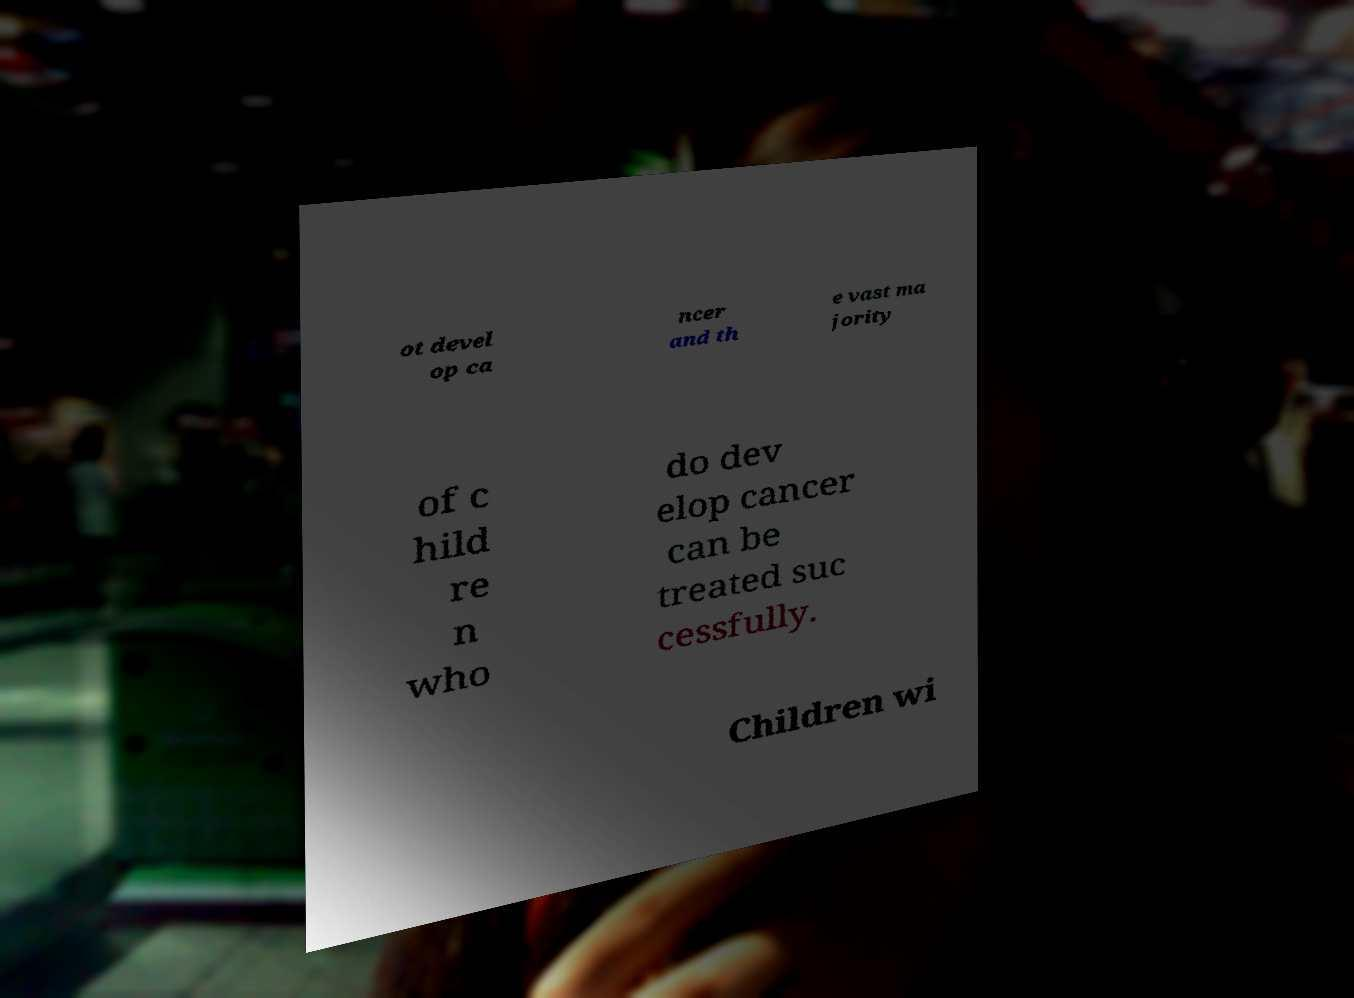There's text embedded in this image that I need extracted. Can you transcribe it verbatim? ot devel op ca ncer and th e vast ma jority of c hild re n who do dev elop cancer can be treated suc cessfully. Children wi 